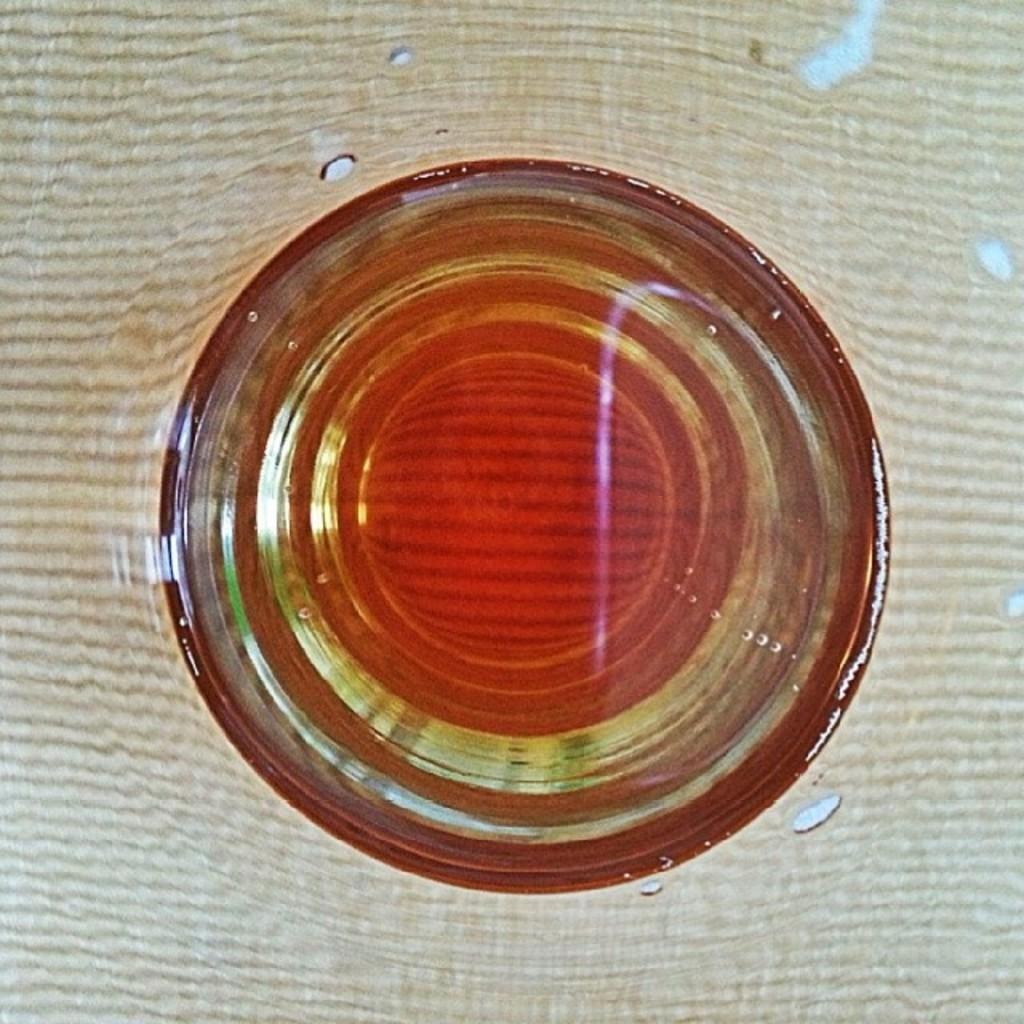What object is in the water in the image? There is a glass in the water. Can you describe the position of the glass in the water? The glass is submerged in the water. What might be the purpose of the glass being in the water? It could be for a demonstration, experiment, or artistic purpose. What type of fireman is depicted in the image? There is no fireman present in the image; it only features a glass in the water. Can you describe the slave's living conditions in the image? There is no slave present in the image; it only features a glass in the water. 